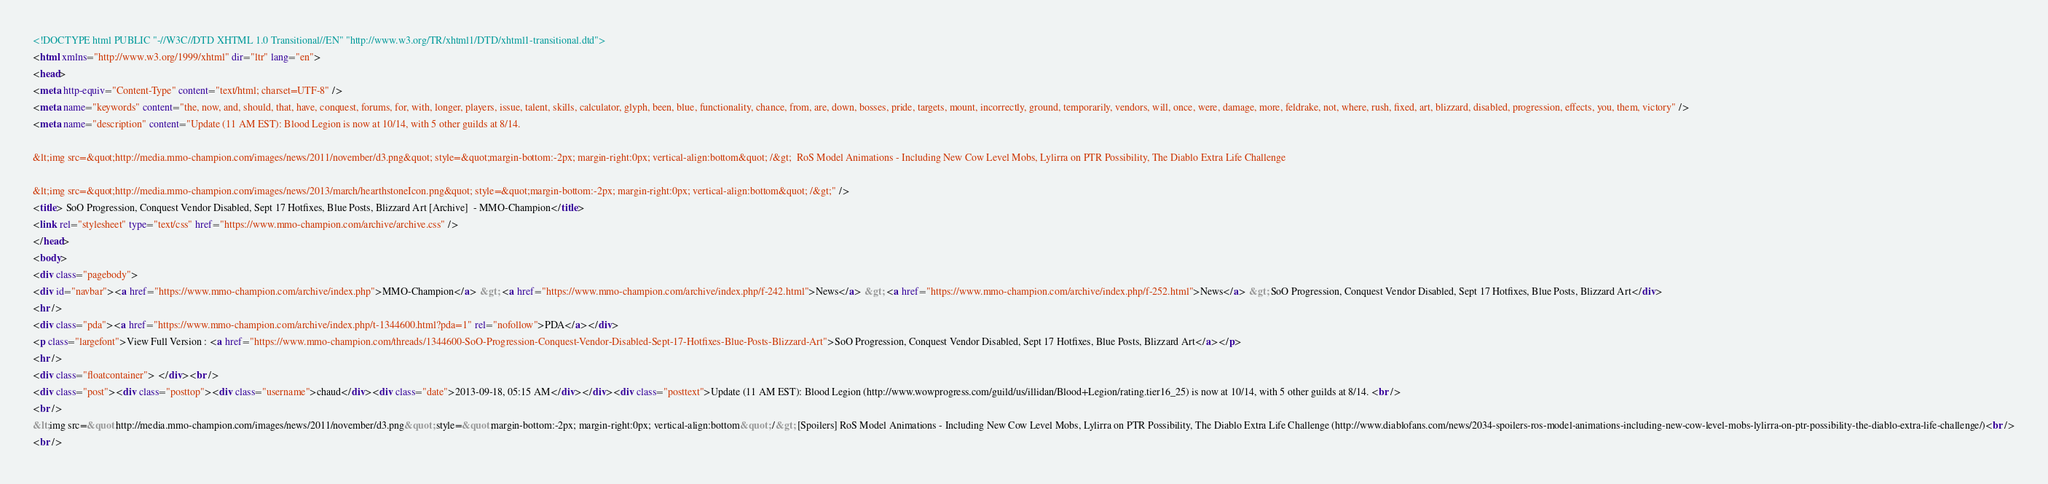Convert code to text. <code><loc_0><loc_0><loc_500><loc_500><_HTML_><!DOCTYPE html PUBLIC "-//W3C//DTD XHTML 1.0 Transitional//EN" "http://www.w3.org/TR/xhtml1/DTD/xhtml1-transitional.dtd">
<html xmlns="http://www.w3.org/1999/xhtml" dir="ltr" lang="en">
<head>
<meta http-equiv="Content-Type" content="text/html; charset=UTF-8" />
<meta name="keywords" content="the, now, and, should, that, have, conquest, forums, for, with, longer, players, issue, talent, skills, calculator, glyph, been, blue, functionality, chance, from, are, down, bosses, pride, targets, mount, incorrectly, ground, temporarily, vendors, will, once, were, damage, more, feldrake, not, where, rush, fixed, art, blizzard, disabled, progression, effects, you, them, victory" />
<meta name="description" content="Update (11 AM EST): Blood Legion is now at 10/14, with 5 other guilds at 8/14.  
 
&lt;img src=&quot;http://media.mmo-champion.com/images/news/2011/november/d3.png&quot; style=&quot;margin-bottom:-2px; margin-right:0px; vertical-align:bottom&quot; /&gt;  RoS Model Animations - Including New Cow Level Mobs, Lylirra on PTR Possibility, The Diablo Extra Life Challenge 
 
&lt;img src=&quot;http://media.mmo-champion.com/images/news/2013/march/hearthstoneIcon.png&quot; style=&quot;margin-bottom:-2px; margin-right:0px; vertical-align:bottom&quot; /&gt;" />
<title> SoO Progression, Conquest Vendor Disabled, Sept 17 Hotfixes, Blue Posts, Blizzard Art [Archive]  - MMO-Champion</title>
<link rel="stylesheet" type="text/css" href="https://www.mmo-champion.com/archive/archive.css" />
</head>
<body>
<div class="pagebody">
<div id="navbar"><a href="https://www.mmo-champion.com/archive/index.php">MMO-Champion</a> &gt; <a href="https://www.mmo-champion.com/archive/index.php/f-242.html">News</a> &gt; <a href="https://www.mmo-champion.com/archive/index.php/f-252.html">News</a> &gt; SoO Progression, Conquest Vendor Disabled, Sept 17 Hotfixes, Blue Posts, Blizzard Art</div>
<hr />
<div class="pda"><a href="https://www.mmo-champion.com/archive/index.php/t-1344600.html?pda=1" rel="nofollow">PDA</a></div>
<p class="largefont">View Full Version : <a href="https://www.mmo-champion.com/threads/1344600-SoO-Progression-Conquest-Vendor-Disabled-Sept-17-Hotfixes-Blue-Posts-Blizzard-Art">SoO Progression, Conquest Vendor Disabled, Sept 17 Hotfixes, Blue Posts, Blizzard Art</a></p>
<hr />
<div class="floatcontainer"> </div><br />
<div class="post"><div class="posttop"><div class="username">chaud</div><div class="date">2013-09-18, 05:15 AM</div></div><div class="posttext">Update (11 AM EST): Blood Legion (http://www.wowprogress.com/guild/us/illidan/Blood+Legion/rating.tier16_25) is now at 10/14, with 5 other guilds at 8/14. <br />
<br />
&lt;img src=&quot;http://media.mmo-champion.com/images/news/2011/november/d3.png&quot; style=&quot;margin-bottom:-2px; margin-right:0px; vertical-align:bottom&quot; /&gt; [Spoilers] RoS Model Animations - Including New Cow Level Mobs, Lylirra on PTR Possibility, The Diablo Extra Life Challenge (http://www.diablofans.com/news/2034-spoilers-ros-model-animations-including-new-cow-level-mobs-lylirra-on-ptr-possibility-the-diablo-extra-life-challenge/)<br />
<br /></code> 